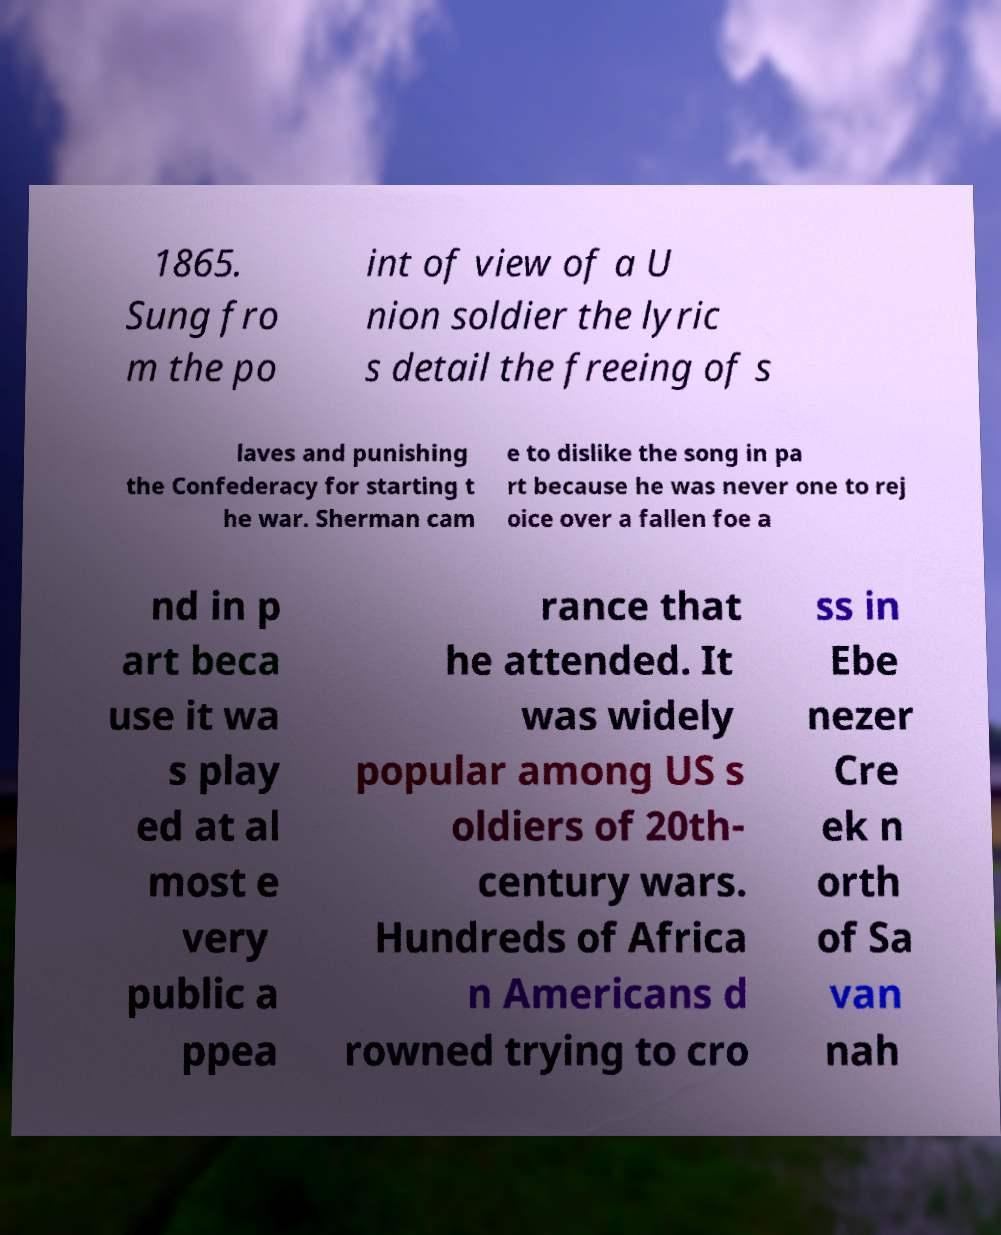Please read and relay the text visible in this image. What does it say? 1865. Sung fro m the po int of view of a U nion soldier the lyric s detail the freeing of s laves and punishing the Confederacy for starting t he war. Sherman cam e to dislike the song in pa rt because he was never one to rej oice over a fallen foe a nd in p art beca use it wa s play ed at al most e very public a ppea rance that he attended. It was widely popular among US s oldiers of 20th- century wars. Hundreds of Africa n Americans d rowned trying to cro ss in Ebe nezer Cre ek n orth of Sa van nah 